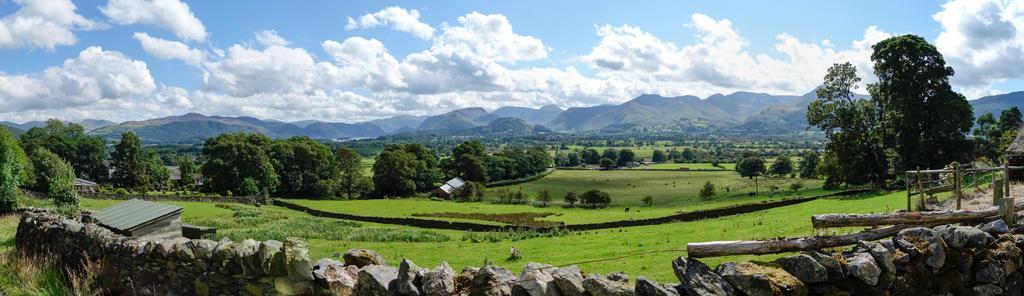Could you give a brief overview of what you see in this image? At the bottom of the image there is a stone wall. At the right side of the image behind the stones wall there is a wooden fencing. And at the left side of the image there are trees and in front of the wall there is a roof. Behind the stones wall on the ground there is grass and also there are many trees. In the background there are many trees. Behind the trees there are many hills. At the top of the image there is a sky with clouds. 